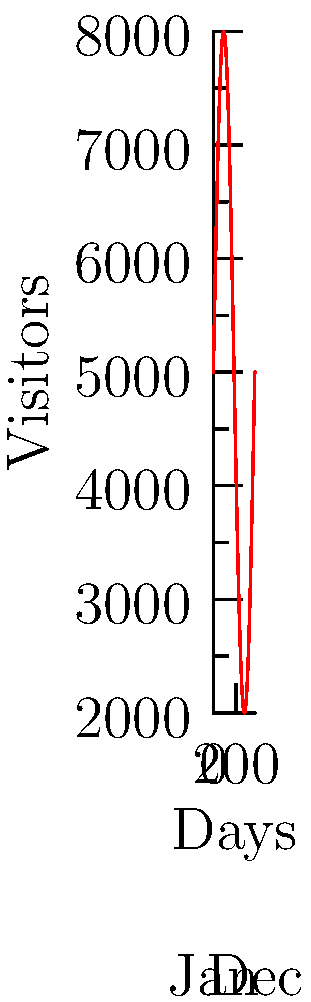The graph represents the number of daily visitors to Namsan Seoul Tower throughout the year. If the function modeling the number of visitors is given by $f(x) = 5000 + 3000\sin(\frac{2\pi x}{365})$, where $x$ is the day of the year (from 0 to 364), calculate the total number of visitors for the entire year. To find the total number of visitors for the entire year, we need to calculate the area under the curve from day 0 to day 364. This can be done using a definite integral.

Step 1: Set up the definite integral
$$\int_0^{364} (5000 + 3000\sin(\frac{2\pi x}{365})) dx$$

Step 2: Integrate the function
$$[5000x - \frac{3000 \cdot 365}{2\pi} \cos(\frac{2\pi x}{365})]_0^{364}$$

Step 3: Evaluate the integral at the upper and lower bounds
Upper bound: $5000(364) - \frac{3000 \cdot 365}{2\pi} \cos(\frac{2\pi \cdot 364}{365})$
Lower bound: $5000(0) - \frac{3000 \cdot 365}{2\pi} \cos(\frac{2\pi \cdot 0}{365}) = -\frac{3000 \cdot 365}{2\pi}$

Step 4: Subtract the lower bound from the upper bound
$1,820,000 - \frac{3000 \cdot 365}{2\pi} \cos(\frac{2\pi \cdot 364}{365}) + \frac{3000 \cdot 365}{2\pi}$

Step 5: Simplify
$1,820,000 + \frac{3000 \cdot 365}{2\pi} (1 - \cos(\frac{2\pi \cdot 364}{365})) \approx 1,825,000$
Answer: Approximately 1,825,000 visitors 